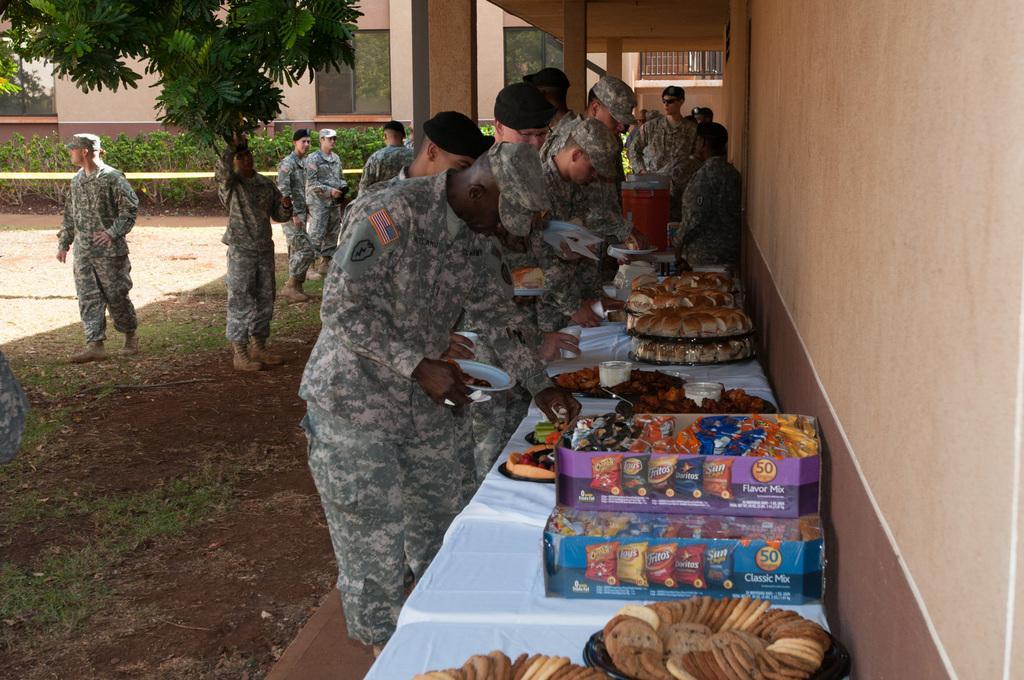How would you summarize this image in a sentence or two? In this image I can see the group of people with the uniforms. In-front of these people I can see the table. On the table there are food items. I can see few people holding the palates. In the background I can see many trees and the building. 